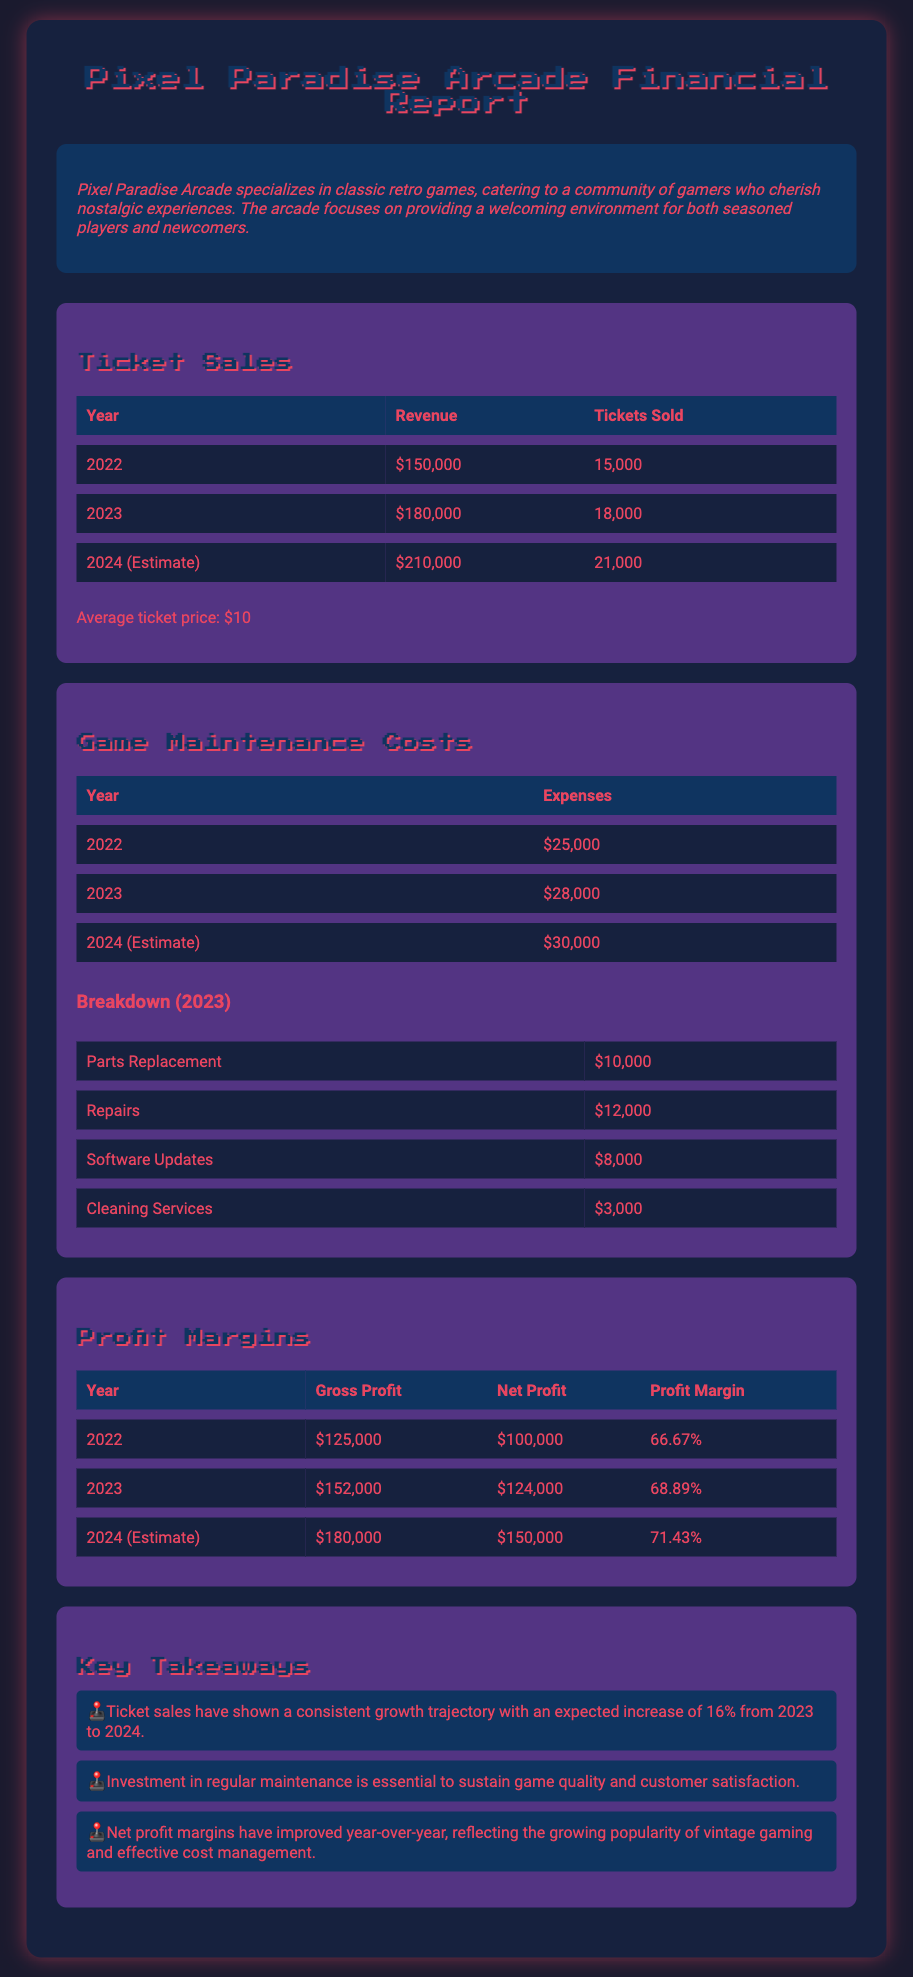What was the ticket revenue for 2023? The ticket revenue for 2023 is listed in the table as $180,000.
Answer: $180,000 How many tickets were sold in 2022? The number of tickets sold in 2022 is provided in the table as 15,000.
Answer: 15,000 What are the estimated game maintenance costs for 2024? The estimated game maintenance costs for 2024 are detailed in the table as $30,000.
Answer: $30,000 What is the profit margin for 2023? The profit margin for 2023 is specified in the table as 68.89%.
Answer: 68.89% How much did Pixel Paradise Arcade spend on repairs in 2023? The expenses for repairs in 2023 are broken down in the table as $12,000.
Answer: $12,000 What was the gross profit in 2022? The gross profit for 2022 is given in the table as $125,000.
Answer: $125,000 What is the expected increase in ticket sales from 2023 to 2024? The expected increase in ticket sales from 2023 to 2024 is mentioned as 16%.
Answer: 16% Which year had the highest net profit? The year with the highest net profit, as shown in the table, is 2024 with $150,000.
Answer: 2024 What is the average ticket price? The average ticket price is stated in the document as $10.
Answer: $10 